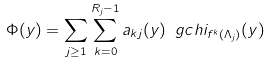<formula> <loc_0><loc_0><loc_500><loc_500>\Phi ( y ) = \sum _ { j \geq 1 } \sum _ { k = 0 } ^ { R _ { j } - 1 } a _ { k j } ( y ) \ g c h i _ { f ^ { k } ( \Lambda _ { j } ) } ( y )</formula> 